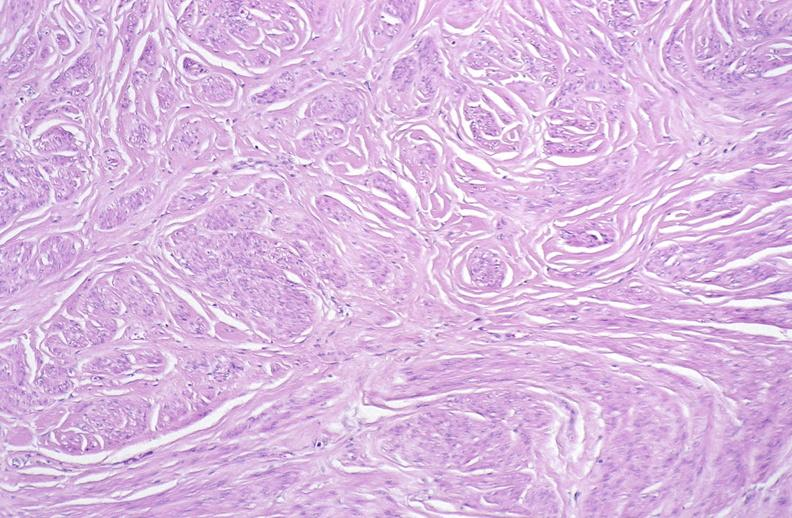s carcinoma metastatic lung present?
Answer the question using a single word or phrase. No 